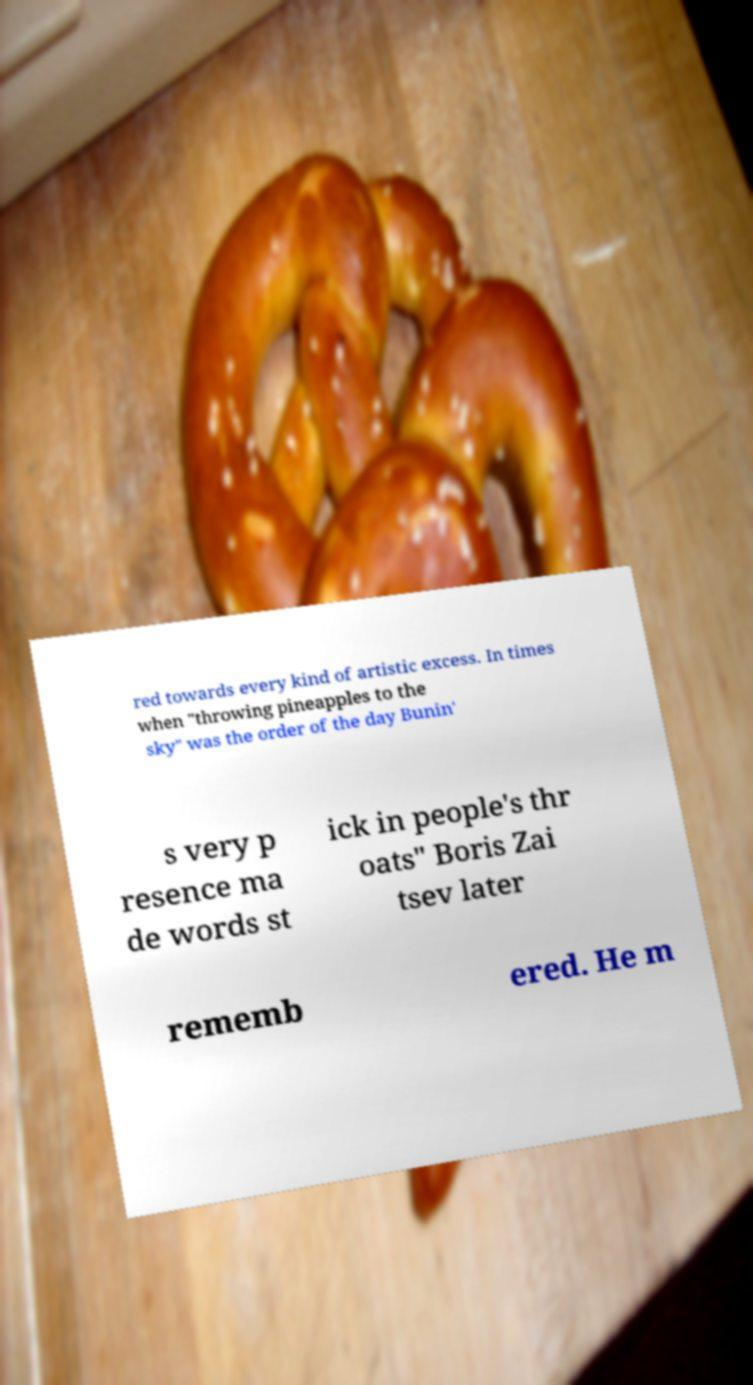Could you assist in decoding the text presented in this image and type it out clearly? red towards every kind of artistic excess. In times when "throwing pineapples to the sky" was the order of the day Bunin' s very p resence ma de words st ick in people's thr oats" Boris Zai tsev later rememb ered. He m 